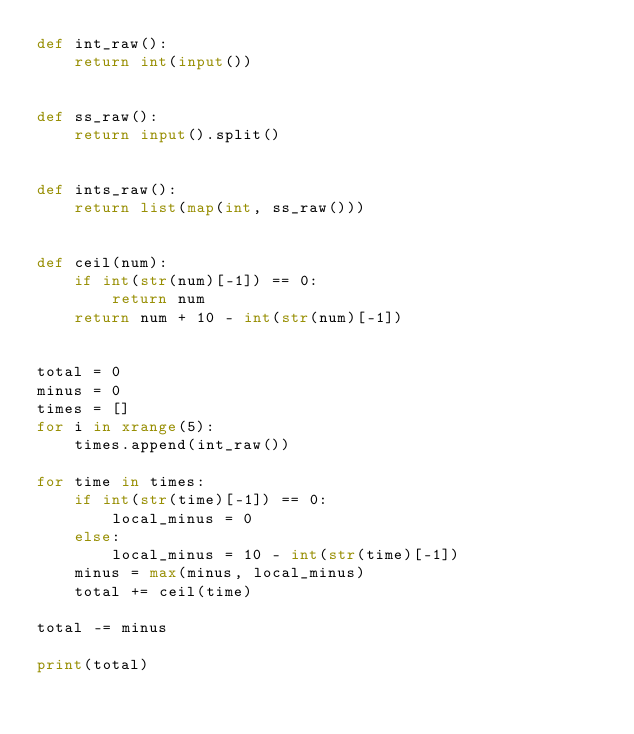<code> <loc_0><loc_0><loc_500><loc_500><_Python_>def int_raw():
    return int(input())


def ss_raw():
    return input().split()


def ints_raw():
    return list(map(int, ss_raw()))


def ceil(num):
    if int(str(num)[-1]) == 0:
        return num
    return num + 10 - int(str(num)[-1])


total = 0
minus = 0
times = []
for i in xrange(5):
    times.append(int_raw())

for time in times:
    if int(str(time)[-1]) == 0:
        local_minus = 0
    else:
        local_minus = 10 - int(str(time)[-1])
    minus = max(minus, local_minus)
    total += ceil(time)

total -= minus

print(total)
</code> 